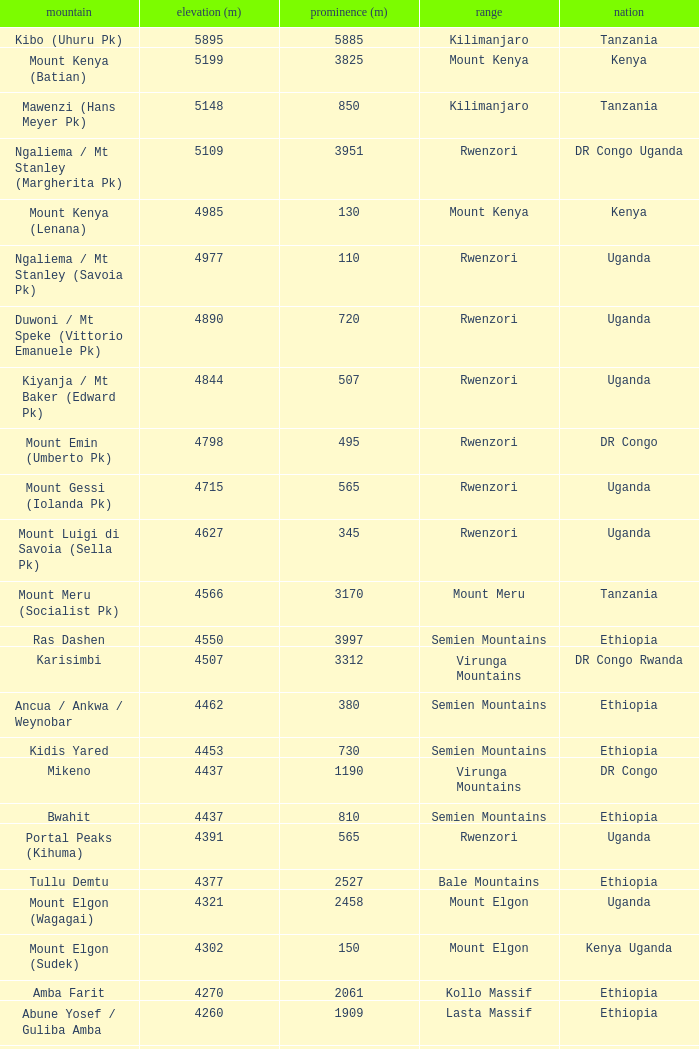Which Country has a Height (m) larger than 4100, and a Range of arsi mountains, and a Mountain of bada? Ethiopia. 